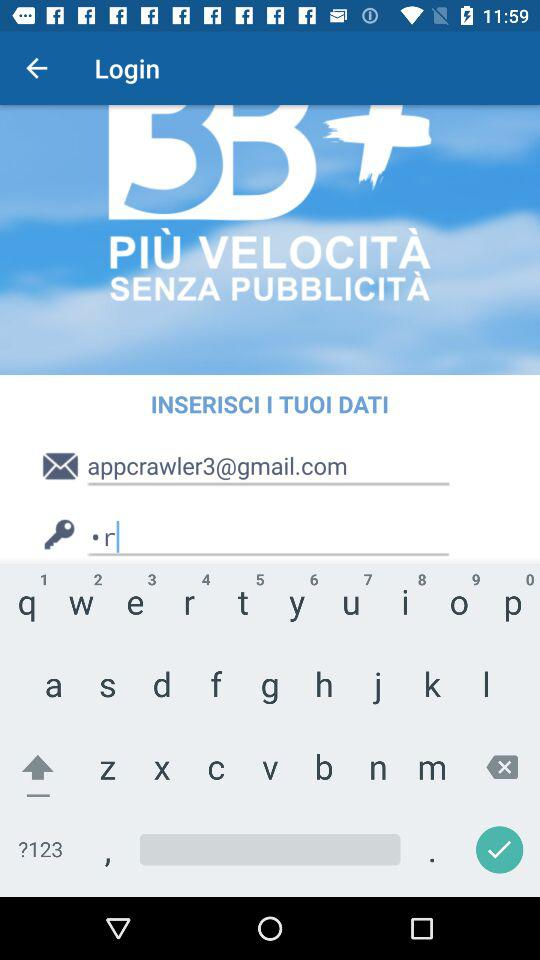How many videos are there in total?
Answer the question using a single word or phrase. 3 